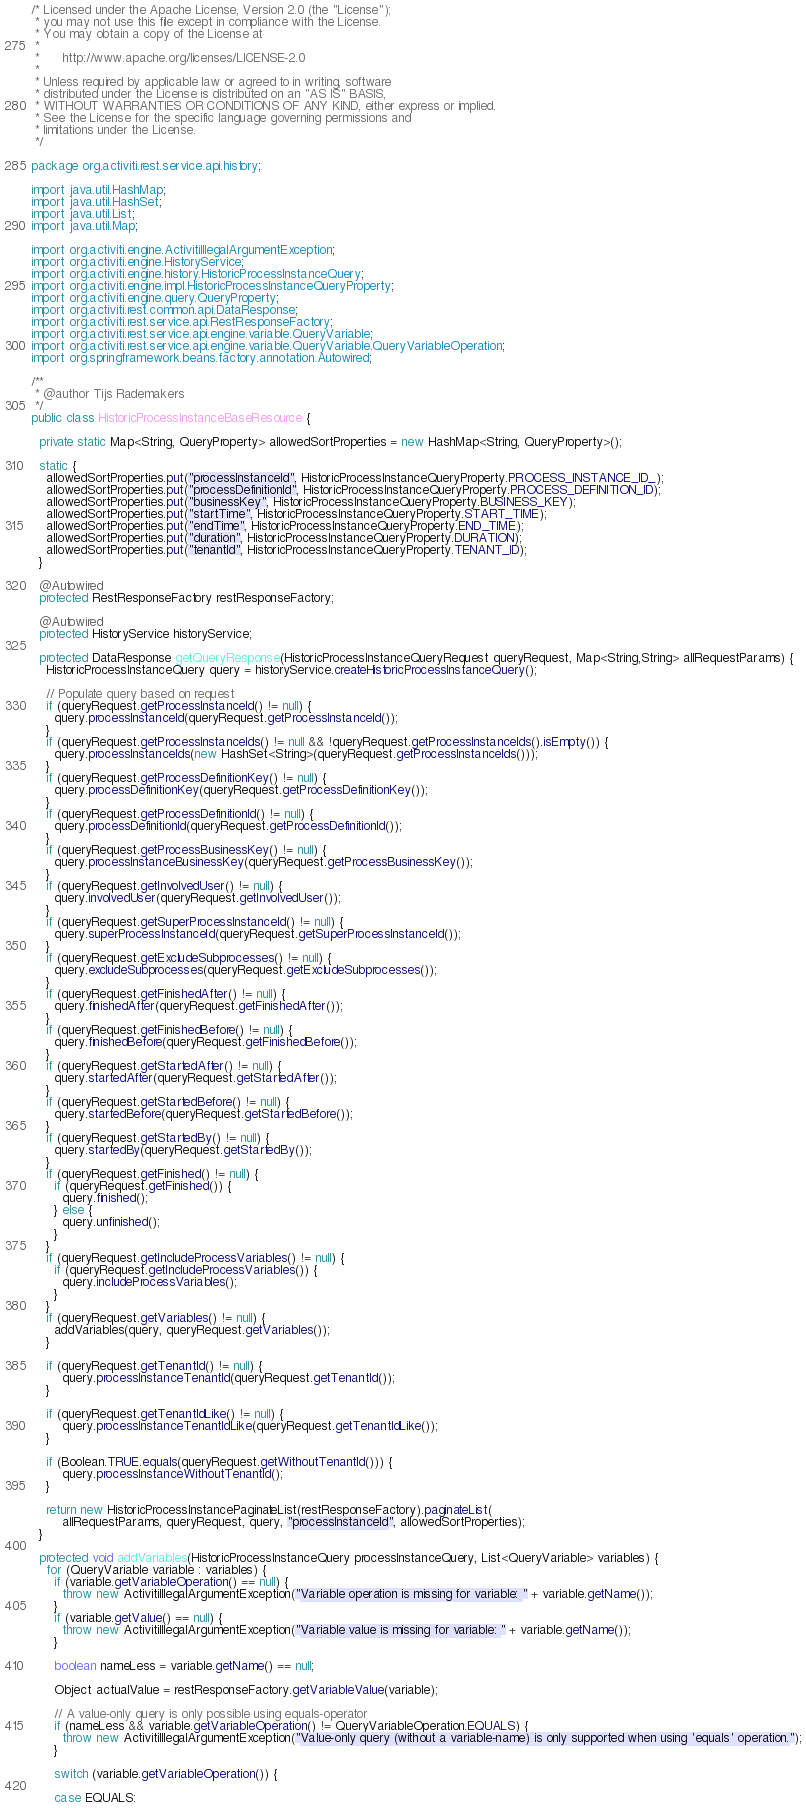<code> <loc_0><loc_0><loc_500><loc_500><_Java_>/* Licensed under the Apache License, Version 2.0 (the "License");
 * you may not use this file except in compliance with the License.
 * You may obtain a copy of the License at
 * 
 *      http://www.apache.org/licenses/LICENSE-2.0
 * 
 * Unless required by applicable law or agreed to in writing, software
 * distributed under the License is distributed on an "AS IS" BASIS,
 * WITHOUT WARRANTIES OR CONDITIONS OF ANY KIND, either express or implied.
 * See the License for the specific language governing permissions and
 * limitations under the License.
 */

package org.activiti.rest.service.api.history;

import java.util.HashMap;
import java.util.HashSet;
import java.util.List;
import java.util.Map;

import org.activiti.engine.ActivitiIllegalArgumentException;
import org.activiti.engine.HistoryService;
import org.activiti.engine.history.HistoricProcessInstanceQuery;
import org.activiti.engine.impl.HistoricProcessInstanceQueryProperty;
import org.activiti.engine.query.QueryProperty;
import org.activiti.rest.common.api.DataResponse;
import org.activiti.rest.service.api.RestResponseFactory;
import org.activiti.rest.service.api.engine.variable.QueryVariable;
import org.activiti.rest.service.api.engine.variable.QueryVariable.QueryVariableOperation;
import org.springframework.beans.factory.annotation.Autowired;

/**
 * @author Tijs Rademakers
 */
public class HistoricProcessInstanceBaseResource {

  private static Map<String, QueryProperty> allowedSortProperties = new HashMap<String, QueryProperty>();

  static {
    allowedSortProperties.put("processInstanceId", HistoricProcessInstanceQueryProperty.PROCESS_INSTANCE_ID_);
    allowedSortProperties.put("processDefinitionId", HistoricProcessInstanceQueryProperty.PROCESS_DEFINITION_ID);
    allowedSortProperties.put("businessKey", HistoricProcessInstanceQueryProperty.BUSINESS_KEY);
    allowedSortProperties.put("startTime", HistoricProcessInstanceQueryProperty.START_TIME);
    allowedSortProperties.put("endTime", HistoricProcessInstanceQueryProperty.END_TIME);
    allowedSortProperties.put("duration", HistoricProcessInstanceQueryProperty.DURATION);
    allowedSortProperties.put("tenantId", HistoricProcessInstanceQueryProperty.TENANT_ID);
  }
  
  @Autowired
  protected RestResponseFactory restResponseFactory;
  
  @Autowired
  protected HistoryService historyService;

  protected DataResponse getQueryResponse(HistoricProcessInstanceQueryRequest queryRequest, Map<String,String> allRequestParams) {
    HistoricProcessInstanceQuery query = historyService.createHistoricProcessInstanceQuery();

    // Populate query based on request
    if (queryRequest.getProcessInstanceId() != null) {
      query.processInstanceId(queryRequest.getProcessInstanceId());
    }
    if (queryRequest.getProcessInstanceIds() != null && !queryRequest.getProcessInstanceIds().isEmpty()) {
      query.processInstanceIds(new HashSet<String>(queryRequest.getProcessInstanceIds()));
    }
    if (queryRequest.getProcessDefinitionKey() != null) {
      query.processDefinitionKey(queryRequest.getProcessDefinitionKey());
    }
    if (queryRequest.getProcessDefinitionId() != null) {
      query.processDefinitionId(queryRequest.getProcessDefinitionId());
    }
    if (queryRequest.getProcessBusinessKey() != null) {
      query.processInstanceBusinessKey(queryRequest.getProcessBusinessKey());
    }
    if (queryRequest.getInvolvedUser() != null) {
      query.involvedUser(queryRequest.getInvolvedUser());
    }
    if (queryRequest.getSuperProcessInstanceId() != null) {
      query.superProcessInstanceId(queryRequest.getSuperProcessInstanceId());
    }
    if (queryRequest.getExcludeSubprocesses() != null) {
      query.excludeSubprocesses(queryRequest.getExcludeSubprocesses());
    }
    if (queryRequest.getFinishedAfter() != null) {
      query.finishedAfter(queryRequest.getFinishedAfter());
    }
    if (queryRequest.getFinishedBefore() != null) {
      query.finishedBefore(queryRequest.getFinishedBefore());
    }
    if (queryRequest.getStartedAfter() != null) {
      query.startedAfter(queryRequest.getStartedAfter());
    }
    if (queryRequest.getStartedBefore() != null) {
      query.startedBefore(queryRequest.getStartedBefore());
    }
    if (queryRequest.getStartedBy() != null) {
      query.startedBy(queryRequest.getStartedBy());
    }
    if (queryRequest.getFinished() != null) {
      if (queryRequest.getFinished()) {
        query.finished();
      } else {
        query.unfinished();
      }
    }
    if (queryRequest.getIncludeProcessVariables() != null) {
      if (queryRequest.getIncludeProcessVariables()) {
        query.includeProcessVariables();
      }
    }
    if (queryRequest.getVariables() != null) {
      addVariables(query, queryRequest.getVariables());
    }
    
    if (queryRequest.getTenantId() != null) {
    	query.processInstanceTenantId(queryRequest.getTenantId());
    }
    
    if (queryRequest.getTenantIdLike() != null) {
    	query.processInstanceTenantIdLike(queryRequest.getTenantIdLike());
    }
    
    if (Boolean.TRUE.equals(queryRequest.getWithoutTenantId())) {
    	query.processInstanceWithoutTenantId();
    }

    return new HistoricProcessInstancePaginateList(restResponseFactory).paginateList(
        allRequestParams, queryRequest, query, "processInstanceId", allowedSortProperties);
  }

  protected void addVariables(HistoricProcessInstanceQuery processInstanceQuery, List<QueryVariable> variables) {
    for (QueryVariable variable : variables) {
      if (variable.getVariableOperation() == null) {
        throw new ActivitiIllegalArgumentException("Variable operation is missing for variable: " + variable.getName());
      }
      if (variable.getValue() == null) {
        throw new ActivitiIllegalArgumentException("Variable value is missing for variable: " + variable.getName());
      }

      boolean nameLess = variable.getName() == null;

      Object actualValue = restResponseFactory.getVariableValue(variable);

      // A value-only query is only possible using equals-operator
      if (nameLess && variable.getVariableOperation() != QueryVariableOperation.EQUALS) {
        throw new ActivitiIllegalArgumentException("Value-only query (without a variable-name) is only supported when using 'equals' operation.");
      }

      switch (variable.getVariableOperation()) {

      case EQUALS:</code> 